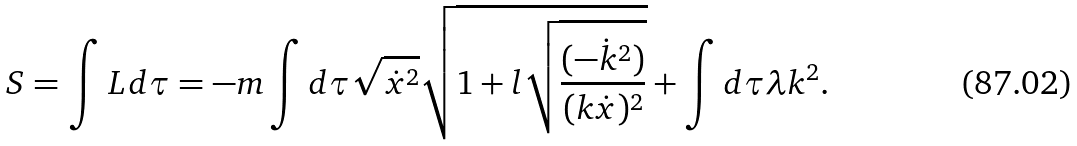Convert formula to latex. <formula><loc_0><loc_0><loc_500><loc_500>S = \int L d \tau = - m \int d \tau \sqrt { \dot { x } ^ { 2 } } \sqrt { 1 + l \sqrt { \frac { ( - \dot { k } ^ { 2 } ) } { ( k \dot { x } ) ^ { 2 } } } } + \int d \tau \lambda k ^ { 2 } .</formula> 